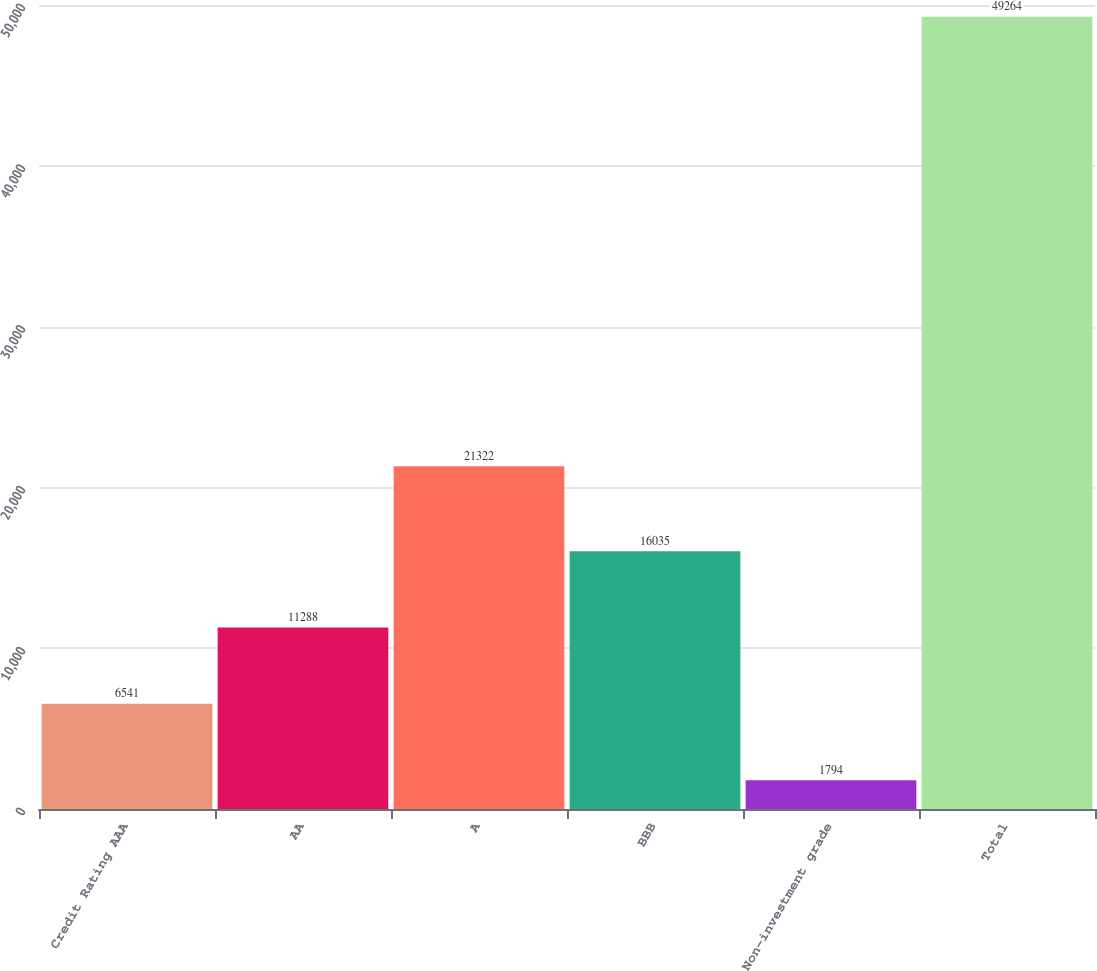Convert chart. <chart><loc_0><loc_0><loc_500><loc_500><bar_chart><fcel>Credit Rating AAA<fcel>AA<fcel>A<fcel>BBB<fcel>Non-investment grade<fcel>Total<nl><fcel>6541<fcel>11288<fcel>21322<fcel>16035<fcel>1794<fcel>49264<nl></chart> 